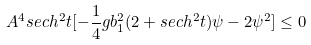Convert formula to latex. <formula><loc_0><loc_0><loc_500><loc_500>A ^ { 4 } s e c h ^ { 2 } t [ - \frac { 1 } { 4 } g b _ { 1 } ^ { 2 } ( 2 + s e c h ^ { 2 } t ) \psi - 2 \psi ^ { 2 } ] \leq 0</formula> 